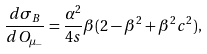Convert formula to latex. <formula><loc_0><loc_0><loc_500><loc_500>\frac { d \sigma _ { B } } { d O _ { \mu _ { - } } } = \frac { \alpha ^ { 2 } } { 4 s } \beta ( 2 - \beta ^ { 2 } + \beta ^ { 2 } c ^ { 2 } ) ,</formula> 